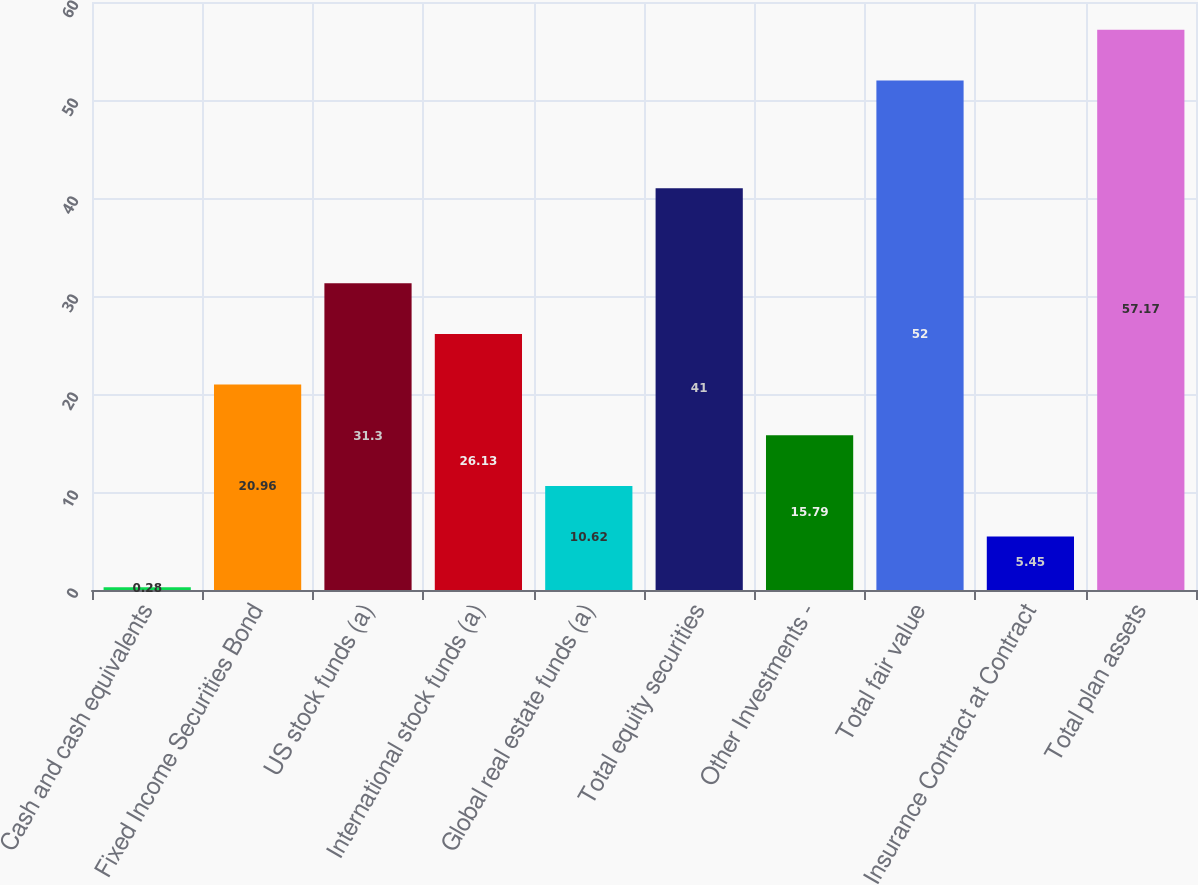Convert chart. <chart><loc_0><loc_0><loc_500><loc_500><bar_chart><fcel>Cash and cash equivalents<fcel>Fixed Income Securities Bond<fcel>US stock funds (a)<fcel>International stock funds (a)<fcel>Global real estate funds (a)<fcel>Total equity securities<fcel>Other Investments -<fcel>Total fair value<fcel>Insurance Contract at Contract<fcel>Total plan assets<nl><fcel>0.28<fcel>20.96<fcel>31.3<fcel>26.13<fcel>10.62<fcel>41<fcel>15.79<fcel>52<fcel>5.45<fcel>57.17<nl></chart> 